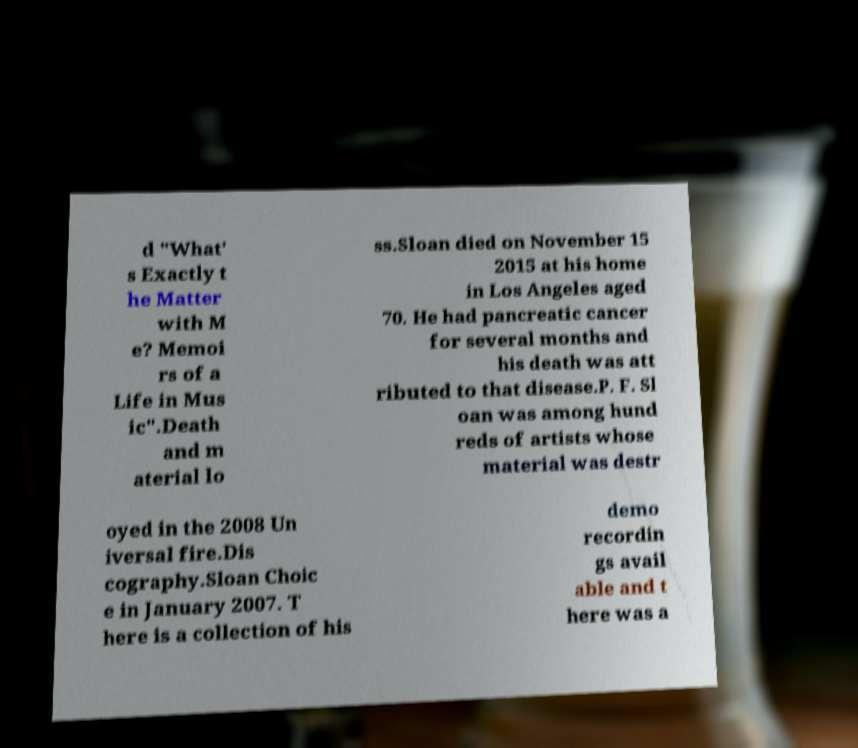Could you assist in decoding the text presented in this image and type it out clearly? d "What' s Exactly t he Matter with M e? Memoi rs of a Life in Mus ic".Death and m aterial lo ss.Sloan died on November 15 2015 at his home in Los Angeles aged 70. He had pancreatic cancer for several months and his death was att ributed to that disease.P. F. Sl oan was among hund reds of artists whose material was destr oyed in the 2008 Un iversal fire.Dis cography.Sloan Choic e in January 2007. T here is a collection of his demo recordin gs avail able and t here was a 